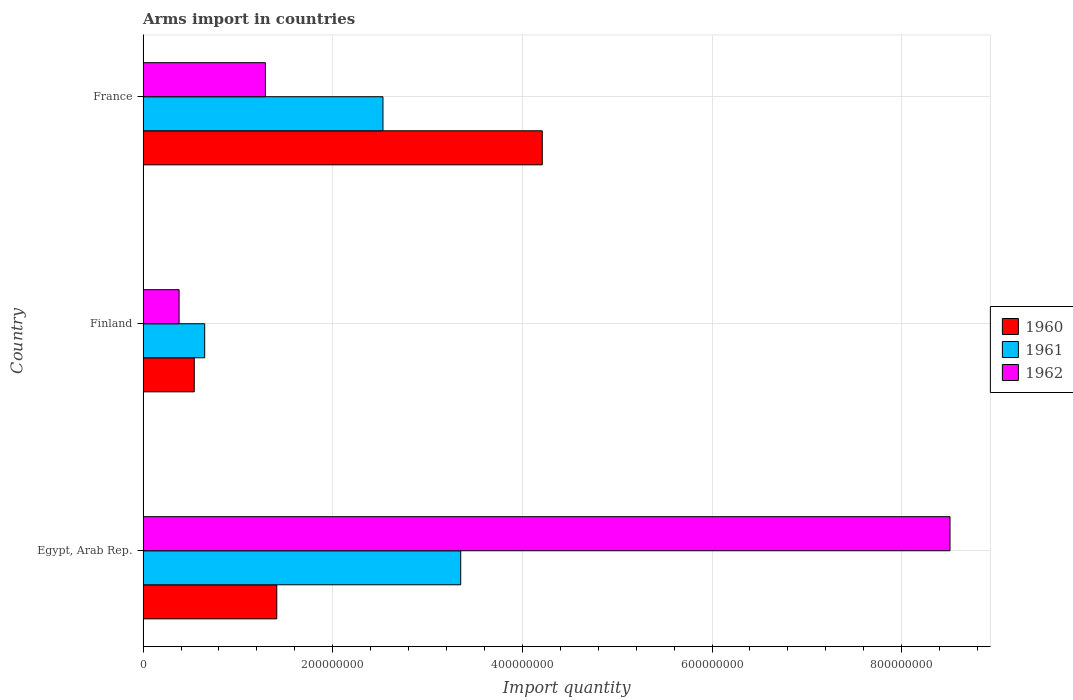How many different coloured bars are there?
Keep it short and to the point. 3. Are the number of bars on each tick of the Y-axis equal?
Keep it short and to the point. Yes. How many bars are there on the 3rd tick from the top?
Keep it short and to the point. 3. What is the total arms import in 1962 in Finland?
Your answer should be compact. 3.80e+07. Across all countries, what is the maximum total arms import in 1961?
Make the answer very short. 3.35e+08. Across all countries, what is the minimum total arms import in 1961?
Ensure brevity in your answer.  6.50e+07. In which country was the total arms import in 1960 maximum?
Your response must be concise. France. What is the total total arms import in 1960 in the graph?
Offer a very short reply. 6.16e+08. What is the difference between the total arms import in 1962 in Finland and that in France?
Your answer should be very brief. -9.10e+07. What is the difference between the total arms import in 1960 in France and the total arms import in 1961 in Egypt, Arab Rep.?
Provide a succinct answer. 8.60e+07. What is the average total arms import in 1961 per country?
Ensure brevity in your answer.  2.18e+08. What is the difference between the total arms import in 1960 and total arms import in 1961 in Finland?
Ensure brevity in your answer.  -1.10e+07. What is the ratio of the total arms import in 1962 in Egypt, Arab Rep. to that in Finland?
Keep it short and to the point. 22.39. Is the total arms import in 1962 in Egypt, Arab Rep. less than that in Finland?
Your answer should be very brief. No. Is the difference between the total arms import in 1960 in Egypt, Arab Rep. and France greater than the difference between the total arms import in 1961 in Egypt, Arab Rep. and France?
Keep it short and to the point. No. What is the difference between the highest and the second highest total arms import in 1960?
Ensure brevity in your answer.  2.80e+08. What is the difference between the highest and the lowest total arms import in 1960?
Ensure brevity in your answer.  3.67e+08. In how many countries, is the total arms import in 1962 greater than the average total arms import in 1962 taken over all countries?
Keep it short and to the point. 1. Is the sum of the total arms import in 1961 in Finland and France greater than the maximum total arms import in 1960 across all countries?
Your response must be concise. No. What does the 2nd bar from the top in Egypt, Arab Rep. represents?
Offer a very short reply. 1961. What does the 3rd bar from the bottom in France represents?
Your answer should be very brief. 1962. Is it the case that in every country, the sum of the total arms import in 1961 and total arms import in 1960 is greater than the total arms import in 1962?
Offer a very short reply. No. Are the values on the major ticks of X-axis written in scientific E-notation?
Keep it short and to the point. No. Does the graph contain any zero values?
Ensure brevity in your answer.  No. What is the title of the graph?
Ensure brevity in your answer.  Arms import in countries. What is the label or title of the X-axis?
Provide a short and direct response. Import quantity. What is the label or title of the Y-axis?
Offer a very short reply. Country. What is the Import quantity of 1960 in Egypt, Arab Rep.?
Provide a short and direct response. 1.41e+08. What is the Import quantity in 1961 in Egypt, Arab Rep.?
Provide a short and direct response. 3.35e+08. What is the Import quantity of 1962 in Egypt, Arab Rep.?
Offer a very short reply. 8.51e+08. What is the Import quantity of 1960 in Finland?
Your answer should be compact. 5.40e+07. What is the Import quantity of 1961 in Finland?
Make the answer very short. 6.50e+07. What is the Import quantity of 1962 in Finland?
Offer a terse response. 3.80e+07. What is the Import quantity in 1960 in France?
Provide a succinct answer. 4.21e+08. What is the Import quantity in 1961 in France?
Offer a terse response. 2.53e+08. What is the Import quantity in 1962 in France?
Offer a terse response. 1.29e+08. Across all countries, what is the maximum Import quantity in 1960?
Make the answer very short. 4.21e+08. Across all countries, what is the maximum Import quantity of 1961?
Your answer should be compact. 3.35e+08. Across all countries, what is the maximum Import quantity of 1962?
Provide a succinct answer. 8.51e+08. Across all countries, what is the minimum Import quantity of 1960?
Your answer should be compact. 5.40e+07. Across all countries, what is the minimum Import quantity in 1961?
Offer a very short reply. 6.50e+07. Across all countries, what is the minimum Import quantity in 1962?
Offer a very short reply. 3.80e+07. What is the total Import quantity in 1960 in the graph?
Offer a very short reply. 6.16e+08. What is the total Import quantity of 1961 in the graph?
Your answer should be very brief. 6.53e+08. What is the total Import quantity of 1962 in the graph?
Keep it short and to the point. 1.02e+09. What is the difference between the Import quantity in 1960 in Egypt, Arab Rep. and that in Finland?
Make the answer very short. 8.70e+07. What is the difference between the Import quantity in 1961 in Egypt, Arab Rep. and that in Finland?
Offer a very short reply. 2.70e+08. What is the difference between the Import quantity in 1962 in Egypt, Arab Rep. and that in Finland?
Your answer should be very brief. 8.13e+08. What is the difference between the Import quantity in 1960 in Egypt, Arab Rep. and that in France?
Your response must be concise. -2.80e+08. What is the difference between the Import quantity in 1961 in Egypt, Arab Rep. and that in France?
Your answer should be very brief. 8.20e+07. What is the difference between the Import quantity in 1962 in Egypt, Arab Rep. and that in France?
Offer a terse response. 7.22e+08. What is the difference between the Import quantity of 1960 in Finland and that in France?
Offer a very short reply. -3.67e+08. What is the difference between the Import quantity of 1961 in Finland and that in France?
Offer a terse response. -1.88e+08. What is the difference between the Import quantity in 1962 in Finland and that in France?
Offer a terse response. -9.10e+07. What is the difference between the Import quantity in 1960 in Egypt, Arab Rep. and the Import quantity in 1961 in Finland?
Ensure brevity in your answer.  7.60e+07. What is the difference between the Import quantity in 1960 in Egypt, Arab Rep. and the Import quantity in 1962 in Finland?
Offer a terse response. 1.03e+08. What is the difference between the Import quantity of 1961 in Egypt, Arab Rep. and the Import quantity of 1962 in Finland?
Your response must be concise. 2.97e+08. What is the difference between the Import quantity in 1960 in Egypt, Arab Rep. and the Import quantity in 1961 in France?
Offer a very short reply. -1.12e+08. What is the difference between the Import quantity in 1960 in Egypt, Arab Rep. and the Import quantity in 1962 in France?
Give a very brief answer. 1.20e+07. What is the difference between the Import quantity in 1961 in Egypt, Arab Rep. and the Import quantity in 1962 in France?
Your answer should be compact. 2.06e+08. What is the difference between the Import quantity of 1960 in Finland and the Import quantity of 1961 in France?
Offer a terse response. -1.99e+08. What is the difference between the Import quantity in 1960 in Finland and the Import quantity in 1962 in France?
Your response must be concise. -7.50e+07. What is the difference between the Import quantity in 1961 in Finland and the Import quantity in 1962 in France?
Offer a very short reply. -6.40e+07. What is the average Import quantity of 1960 per country?
Your answer should be compact. 2.05e+08. What is the average Import quantity in 1961 per country?
Your response must be concise. 2.18e+08. What is the average Import quantity in 1962 per country?
Keep it short and to the point. 3.39e+08. What is the difference between the Import quantity of 1960 and Import quantity of 1961 in Egypt, Arab Rep.?
Ensure brevity in your answer.  -1.94e+08. What is the difference between the Import quantity of 1960 and Import quantity of 1962 in Egypt, Arab Rep.?
Your response must be concise. -7.10e+08. What is the difference between the Import quantity in 1961 and Import quantity in 1962 in Egypt, Arab Rep.?
Offer a terse response. -5.16e+08. What is the difference between the Import quantity in 1960 and Import quantity in 1961 in Finland?
Your answer should be compact. -1.10e+07. What is the difference between the Import quantity in 1960 and Import quantity in 1962 in Finland?
Provide a succinct answer. 1.60e+07. What is the difference between the Import quantity of 1961 and Import quantity of 1962 in Finland?
Provide a succinct answer. 2.70e+07. What is the difference between the Import quantity of 1960 and Import quantity of 1961 in France?
Provide a succinct answer. 1.68e+08. What is the difference between the Import quantity in 1960 and Import quantity in 1962 in France?
Ensure brevity in your answer.  2.92e+08. What is the difference between the Import quantity in 1961 and Import quantity in 1962 in France?
Your response must be concise. 1.24e+08. What is the ratio of the Import quantity in 1960 in Egypt, Arab Rep. to that in Finland?
Keep it short and to the point. 2.61. What is the ratio of the Import quantity of 1961 in Egypt, Arab Rep. to that in Finland?
Give a very brief answer. 5.15. What is the ratio of the Import quantity of 1962 in Egypt, Arab Rep. to that in Finland?
Offer a terse response. 22.39. What is the ratio of the Import quantity in 1960 in Egypt, Arab Rep. to that in France?
Keep it short and to the point. 0.33. What is the ratio of the Import quantity of 1961 in Egypt, Arab Rep. to that in France?
Provide a succinct answer. 1.32. What is the ratio of the Import quantity in 1962 in Egypt, Arab Rep. to that in France?
Provide a short and direct response. 6.6. What is the ratio of the Import quantity of 1960 in Finland to that in France?
Offer a terse response. 0.13. What is the ratio of the Import quantity of 1961 in Finland to that in France?
Give a very brief answer. 0.26. What is the ratio of the Import quantity in 1962 in Finland to that in France?
Provide a short and direct response. 0.29. What is the difference between the highest and the second highest Import quantity in 1960?
Provide a succinct answer. 2.80e+08. What is the difference between the highest and the second highest Import quantity of 1961?
Your answer should be very brief. 8.20e+07. What is the difference between the highest and the second highest Import quantity of 1962?
Ensure brevity in your answer.  7.22e+08. What is the difference between the highest and the lowest Import quantity in 1960?
Your answer should be compact. 3.67e+08. What is the difference between the highest and the lowest Import quantity in 1961?
Provide a succinct answer. 2.70e+08. What is the difference between the highest and the lowest Import quantity in 1962?
Give a very brief answer. 8.13e+08. 